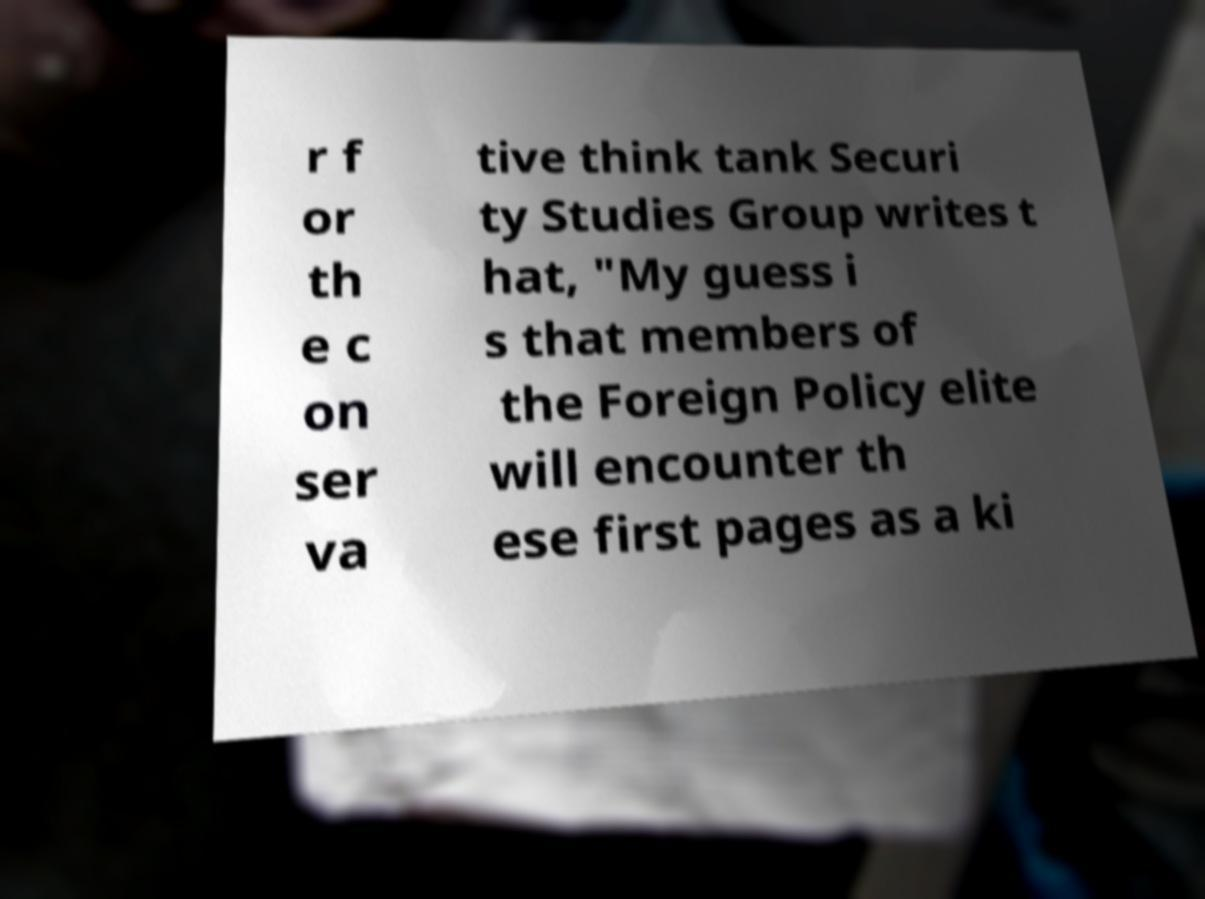Could you assist in decoding the text presented in this image and type it out clearly? r f or th e c on ser va tive think tank Securi ty Studies Group writes t hat, "My guess i s that members of the Foreign Policy elite will encounter th ese first pages as a ki 